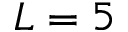<formula> <loc_0><loc_0><loc_500><loc_500>L = 5</formula> 